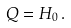Convert formula to latex. <formula><loc_0><loc_0><loc_500><loc_500>Q = H _ { 0 } \, .</formula> 